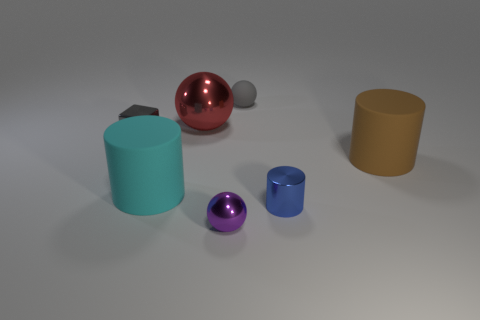What number of large matte things are in front of the large cylinder that is on the right side of the small thing that is in front of the blue cylinder?
Your answer should be very brief. 1. Is the size of the shiny ball that is behind the large brown rubber cylinder the same as the rubber cylinder on the left side of the red sphere?
Make the answer very short. Yes. What material is the other tiny object that is the same shape as the purple thing?
Your answer should be very brief. Rubber. How many big things are blue things or cubes?
Offer a very short reply. 0. What is the material of the large red sphere?
Make the answer very short. Metal. The small thing that is both to the right of the purple shiny object and to the left of the blue metal cylinder is made of what material?
Offer a very short reply. Rubber. Does the metal block have the same color as the small sphere that is on the right side of the purple metal thing?
Make the answer very short. Yes. There is a ball that is the same size as the cyan object; what material is it?
Give a very brief answer. Metal. Are there any large red spheres made of the same material as the tiny purple ball?
Ensure brevity in your answer.  Yes. How many purple metallic objects are there?
Keep it short and to the point. 1. 